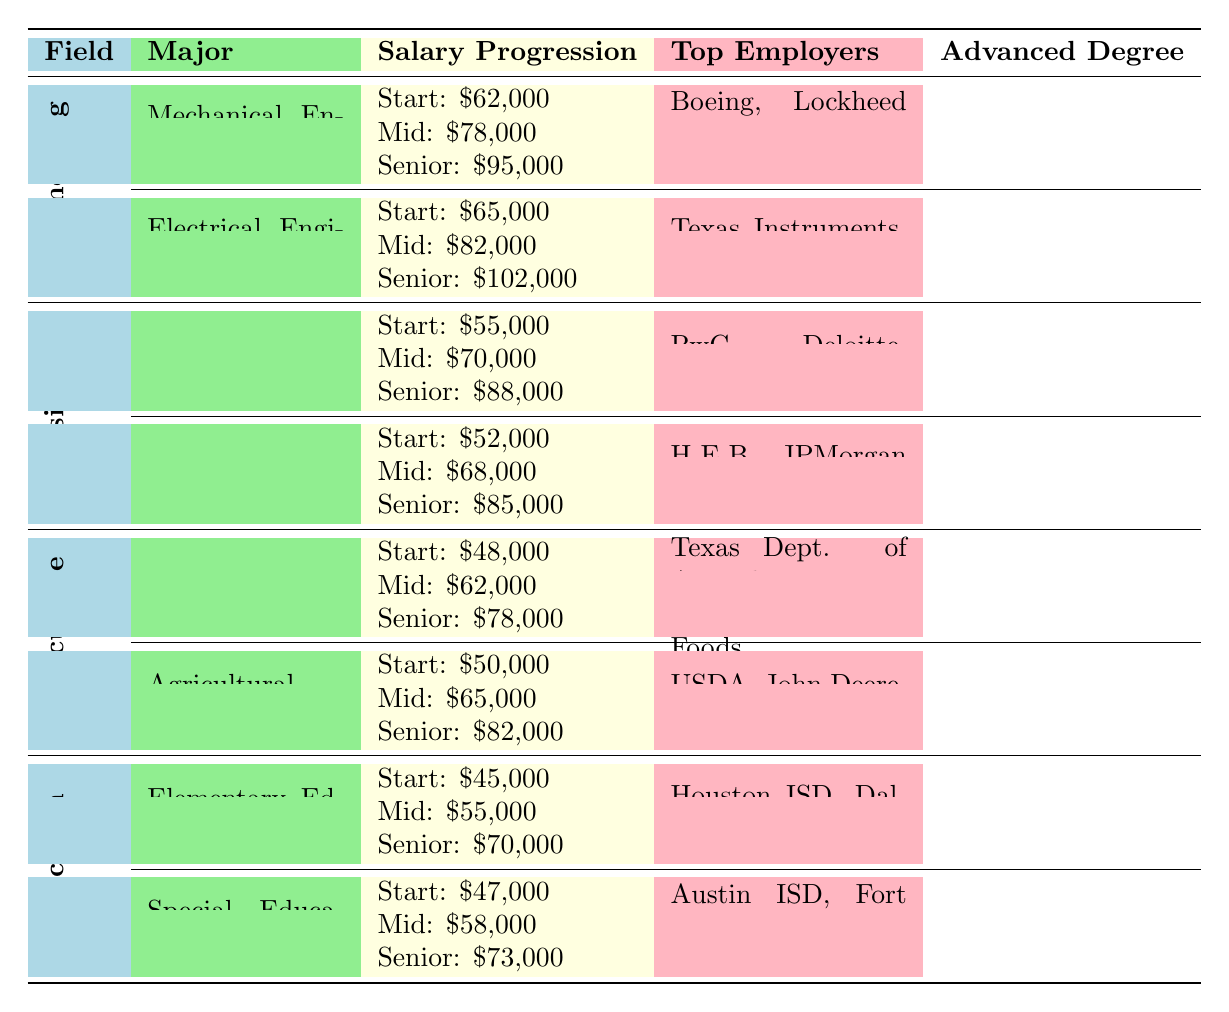What is the average starting salary for Electrical Engineering graduates? The table shows that the average starting salary for Electrical Engineering is listed as $65,000.
Answer: $65,000 Which major has the highest mid-career salary in Engineering? The table lists mid-career salaries for Mechanical Engineering at $78,000 and Electrical Engineering at $82,000. The highest is for Electrical Engineering.
Answer: Electrical Engineering What percentage of alumni from Special Education hold advanced degrees? The table states that 60% of alumni from Special Education have attained advanced degrees.
Answer: 60% What is the difference in average starting salaries between Accounting and Animal Science? The average starting salary for Accounting is $55,000, while for Animal Science it is $48,000. The difference is $55,000 - $48,000 = $7,000.
Answer: $7,000 Which two fields have the lowest average senior-level salaries? In the table, Education (Senior: $70,000) and Agriculture (Senior: $78,000) have the lowest senior-level salaries.
Answer: Education and Agriculture For which majors in Business is the advanced degree attainment percentage higher than 40%? The table shows that Accounting has 45% and Management has 38%, making only Accounting higher than 40%.
Answer: Accounting What are the top employers for Mechanical Engineering alumni? The top employers for Mechanical Engineering are Boeing, Lockheed Martin, and ExxonMobil, as listed in the table.
Answer: Boeing, Lockheed Martin, ExxonMobil What is the average senior-level salary for all majors listed under Agriculture? The senior-level salaries for Animal Science and Agricultural Economics are $78,000 and $82,000 respectively. Therefore, the average is ($78,000 + $82,000) / 2 = $80,000.
Answer: $80,000 Are there any majors where the average starting salary is below $50,000? The table shows that the average starting salary for Animal Science is $48,000, which is below $50,000, confirming a yes.
Answer: Yes In which field do the graduates have the highest average mid-career salary? The table lists the mid-career salaries: Engineering has $78,000 (Mechanical) and $82,000 (Electrical), Business has $70,000 (Accounting) and $68,000 (Management), Agriculture has $62,000 (Animal Science) and $65,000 (Agricultural Economics), and Education has $55,000 (Elementary) and $58,000 (Special). The highest is Electrical Engineering at $82,000.
Answer: Electrical Engineering 